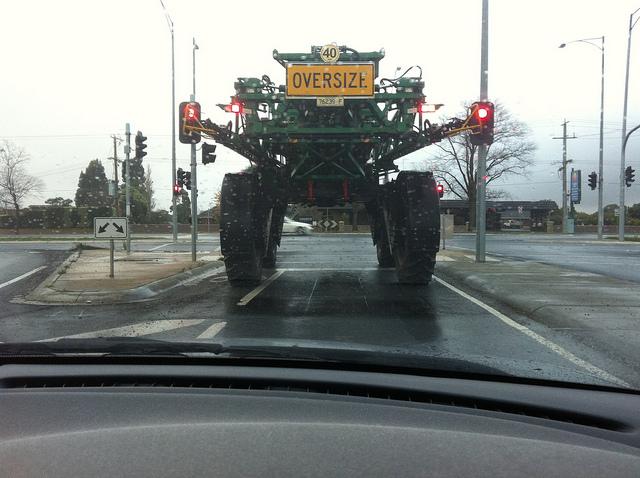What does the truck say?
Write a very short answer. Oversize. Where are the traffic lights?
Quick response, please. On poles. What is the weather looking like?
Concise answer only. Rain. 